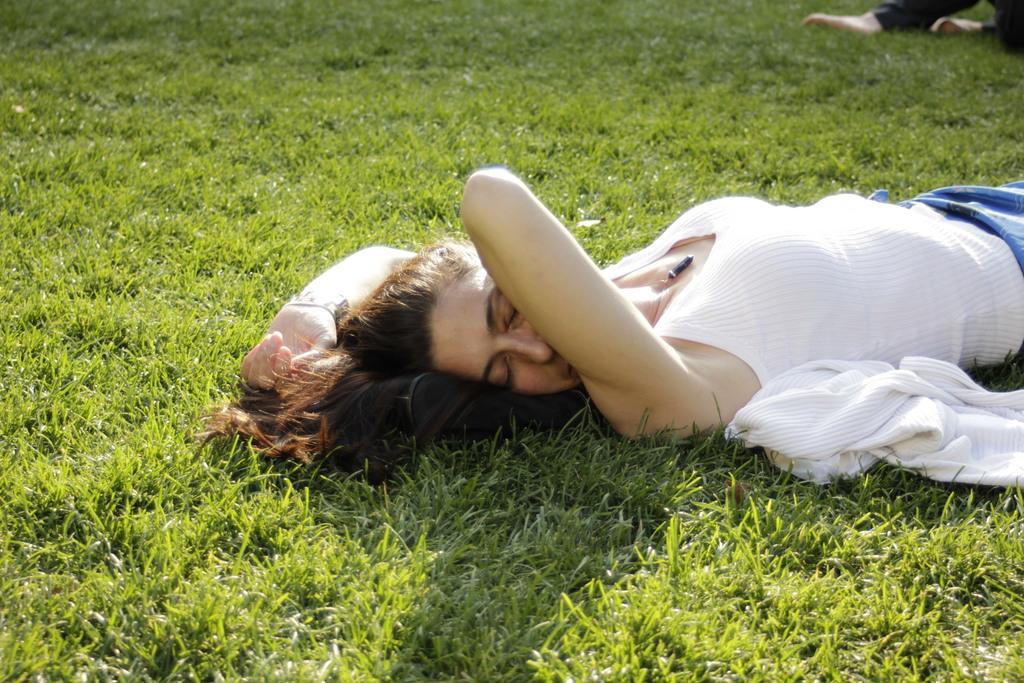How would you summarize this image in a sentence or two? In this image we can see a person, cloth and an object. In the background of the image there is grass. On the right side top of the image we can see a person's legs. 